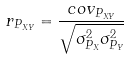Convert formula to latex. <formula><loc_0><loc_0><loc_500><loc_500>r _ { P _ { X Y } } = \frac { c o v _ { P _ { X Y } } } { \sqrt { \sigma _ { P _ { X } } ^ { 2 } \sigma _ { P _ { Y } } ^ { 2 } } }</formula> 